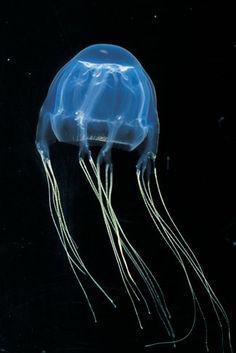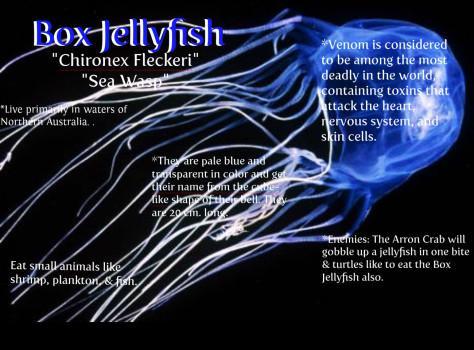The first image is the image on the left, the second image is the image on the right. For the images shown, is this caption "Two jellyfish, one in each image, have similar body shape and color and long thread-like tendrills, but the tendrills are flowing back in differing directions." true? Answer yes or no. Yes. The first image is the image on the left, the second image is the image on the right. Examine the images to the left and right. Is the description "Each image shows a jellyfish with only long string-like tentacles trailing from a gumdrop-shaped body." accurate? Answer yes or no. Yes. 